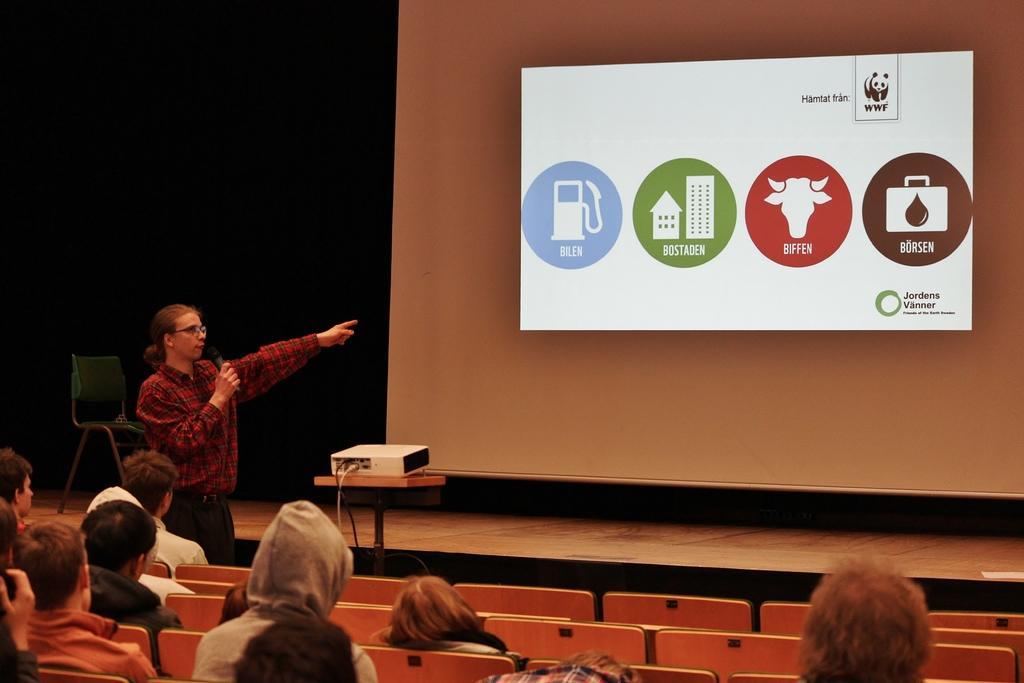In one or two sentences, can you explain what this image depicts? On the left there is a person standing and holding a mic. At the bottom there are chairs and we can see people sitting. In the background there is a screen and we can a projector placed on the stand. 